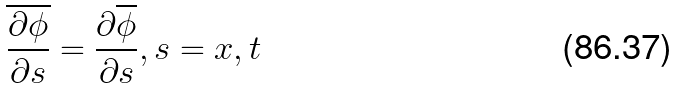Convert formula to latex. <formula><loc_0><loc_0><loc_500><loc_500>\overline { \frac { \partial \phi } { \partial s } } = \frac { \partial \overline { \phi } } { \partial s } , s = x , t</formula> 